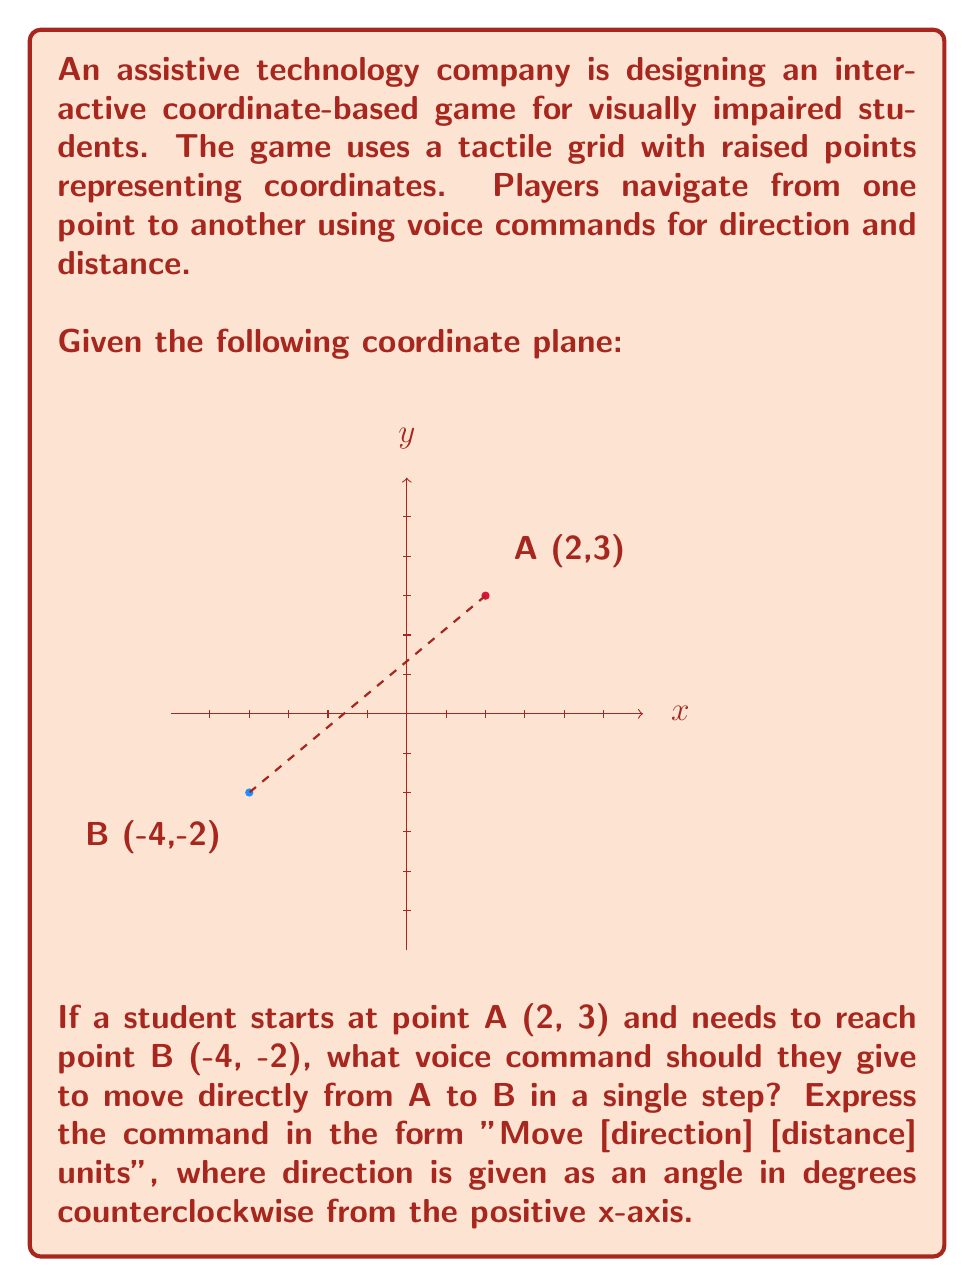Show me your answer to this math problem. To solve this problem, we need to follow these steps:

1) First, calculate the displacement vector from A to B:
   $\Delta x = -4 - 2 = -6$
   $\Delta y = -2 - 3 = -5$

2) The distance can be calculated using the Pythagorean theorem:
   $$d = \sqrt{(\Delta x)^2 + (\Delta y)^2} = \sqrt{(-6)^2 + (-5)^2} = \sqrt{36 + 25} = \sqrt{61} \approx 7.81$$

3) To find the angle, we use the arctangent function:
   $$\theta = \arctan(\frac{\Delta y}{\Delta x}) = \arctan(\frac{-5}{-6}) \approx 39.81°$$

4) However, this angle is in the third quadrant, so we need to add 180° to get the correct angle from the positive x-axis:
   $$39.81° + 180° = 219.81°$$

5) Rounding to the nearest degree for practical voice commands:
   Angle ≈ 220°
   Distance ≈ 8 units (rounding up for easier navigation)

Therefore, the voice command should be: "Move 220 degrees 8 units"
Answer: Move 220 degrees 8 units 